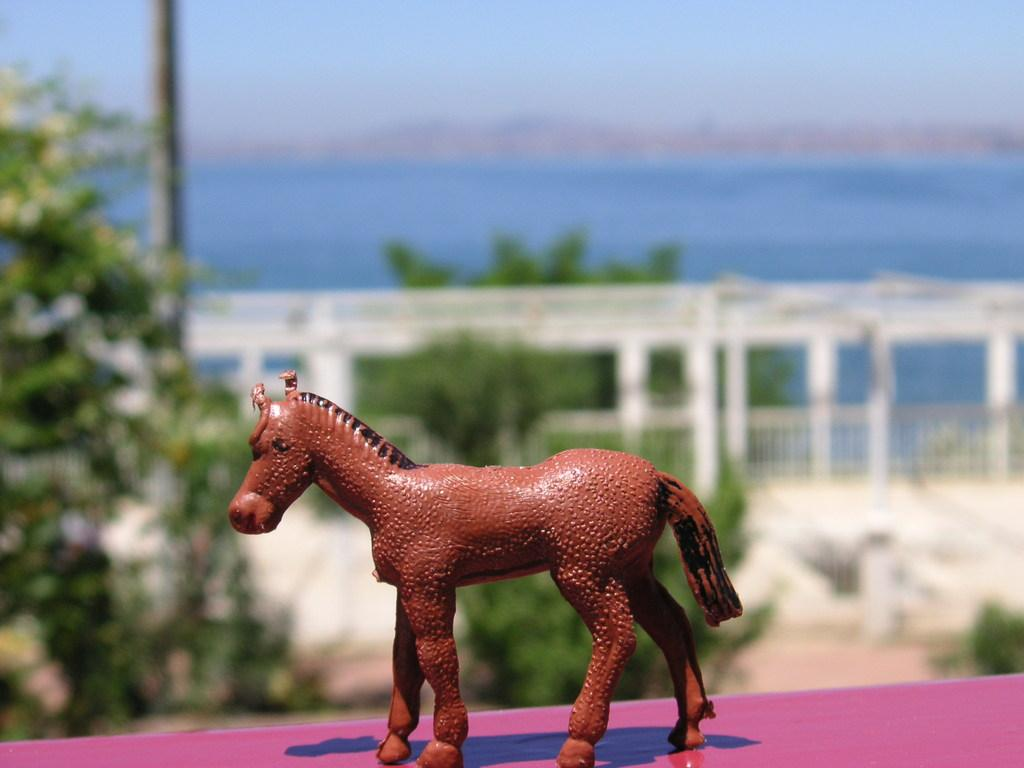What object can be seen in the image? There is a toy in the image. What is the color of the surface the toy is on? The toy is on a pink surface. What can be seen in the background of the image? There is fencing and trees visible in the background of the image. What other object is present in the image? There is a pole in the image. Where is the shelf located in the image? There is no shelf present in the image. What type of mask is being worn by the toy in the image? There is no mask present in the image, as it features a toy on a pink surface with fencing, trees, and a pole in the background. 